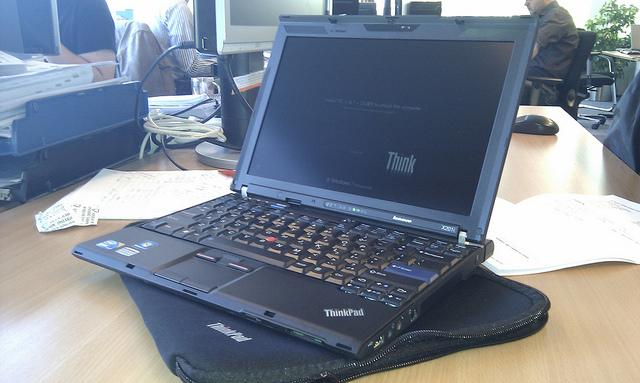What state is the computer most likely in?

Choices:
A) off
B) starting up
C) at desktop
D) processing video starting up 